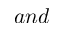Convert formula to latex. <formula><loc_0><loc_0><loc_500><loc_500>a n d</formula> 